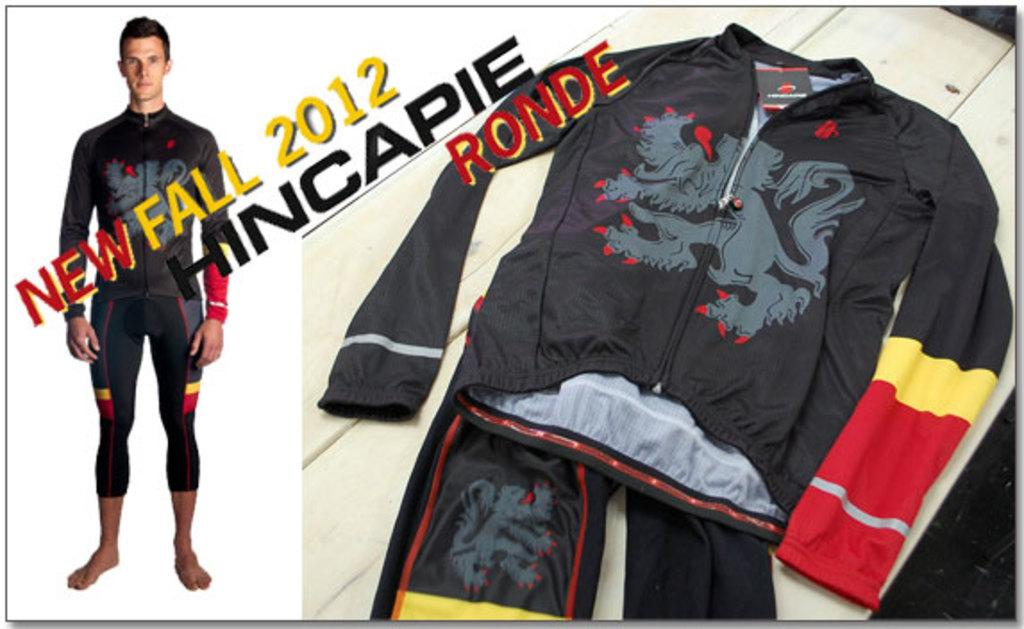<image>
Summarize the visual content of the image. An advertisement for a mens track suit for Fall 2012. 